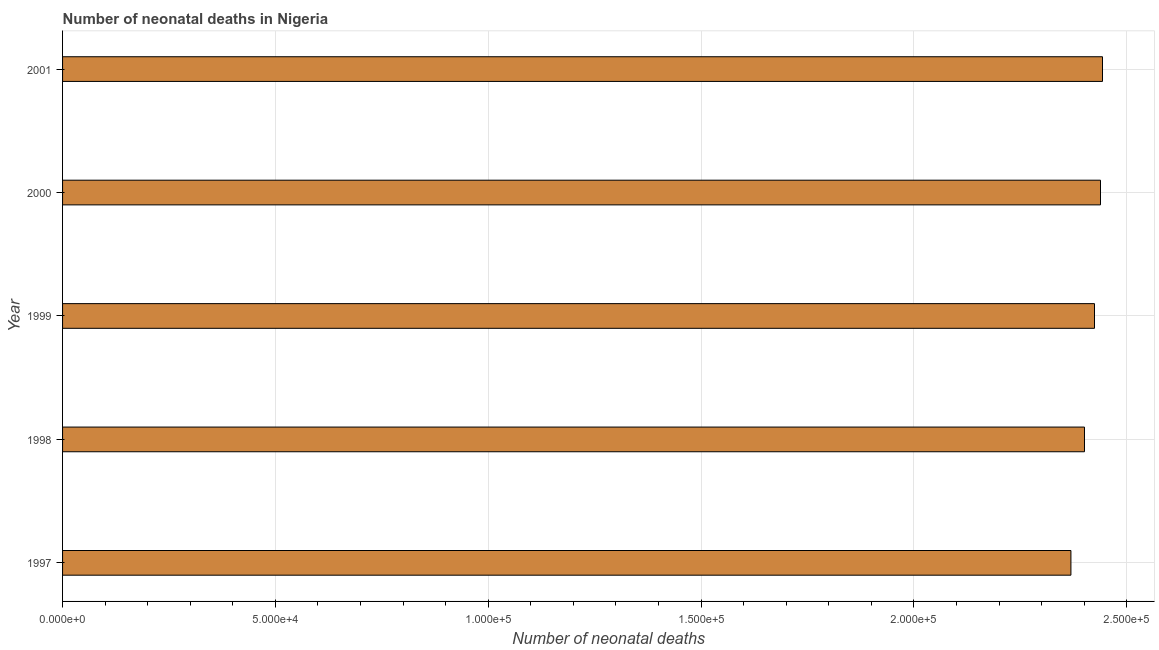Does the graph contain grids?
Ensure brevity in your answer.  Yes. What is the title of the graph?
Your answer should be compact. Number of neonatal deaths in Nigeria. What is the label or title of the X-axis?
Offer a very short reply. Number of neonatal deaths. What is the label or title of the Y-axis?
Offer a very short reply. Year. What is the number of neonatal deaths in 1998?
Give a very brief answer. 2.40e+05. Across all years, what is the maximum number of neonatal deaths?
Provide a short and direct response. 2.44e+05. Across all years, what is the minimum number of neonatal deaths?
Provide a short and direct response. 2.37e+05. In which year was the number of neonatal deaths minimum?
Make the answer very short. 1997. What is the sum of the number of neonatal deaths?
Make the answer very short. 1.21e+06. What is the difference between the number of neonatal deaths in 2000 and 2001?
Your answer should be very brief. -470. What is the average number of neonatal deaths per year?
Offer a terse response. 2.42e+05. What is the median number of neonatal deaths?
Your answer should be compact. 2.42e+05. In how many years, is the number of neonatal deaths greater than 50000 ?
Give a very brief answer. 5. What is the difference between the highest and the second highest number of neonatal deaths?
Your answer should be very brief. 470. What is the difference between the highest and the lowest number of neonatal deaths?
Your answer should be compact. 7418. How many bars are there?
Keep it short and to the point. 5. Are all the bars in the graph horizontal?
Provide a succinct answer. Yes. How many years are there in the graph?
Provide a short and direct response. 5. What is the Number of neonatal deaths in 1997?
Your answer should be very brief. 2.37e+05. What is the Number of neonatal deaths in 1998?
Provide a succinct answer. 2.40e+05. What is the Number of neonatal deaths in 1999?
Your answer should be very brief. 2.42e+05. What is the Number of neonatal deaths of 2000?
Your answer should be very brief. 2.44e+05. What is the Number of neonatal deaths of 2001?
Give a very brief answer. 2.44e+05. What is the difference between the Number of neonatal deaths in 1997 and 1998?
Provide a succinct answer. -3185. What is the difference between the Number of neonatal deaths in 1997 and 1999?
Offer a terse response. -5541. What is the difference between the Number of neonatal deaths in 1997 and 2000?
Offer a very short reply. -6948. What is the difference between the Number of neonatal deaths in 1997 and 2001?
Your answer should be compact. -7418. What is the difference between the Number of neonatal deaths in 1998 and 1999?
Your response must be concise. -2356. What is the difference between the Number of neonatal deaths in 1998 and 2000?
Offer a very short reply. -3763. What is the difference between the Number of neonatal deaths in 1998 and 2001?
Make the answer very short. -4233. What is the difference between the Number of neonatal deaths in 1999 and 2000?
Your response must be concise. -1407. What is the difference between the Number of neonatal deaths in 1999 and 2001?
Ensure brevity in your answer.  -1877. What is the difference between the Number of neonatal deaths in 2000 and 2001?
Provide a short and direct response. -470. What is the ratio of the Number of neonatal deaths in 1997 to that in 1998?
Provide a short and direct response. 0.99. What is the ratio of the Number of neonatal deaths in 1997 to that in 1999?
Offer a very short reply. 0.98. What is the ratio of the Number of neonatal deaths in 1997 to that in 2001?
Give a very brief answer. 0.97. What is the ratio of the Number of neonatal deaths in 1998 to that in 2001?
Keep it short and to the point. 0.98. What is the ratio of the Number of neonatal deaths in 2000 to that in 2001?
Your answer should be very brief. 1. 